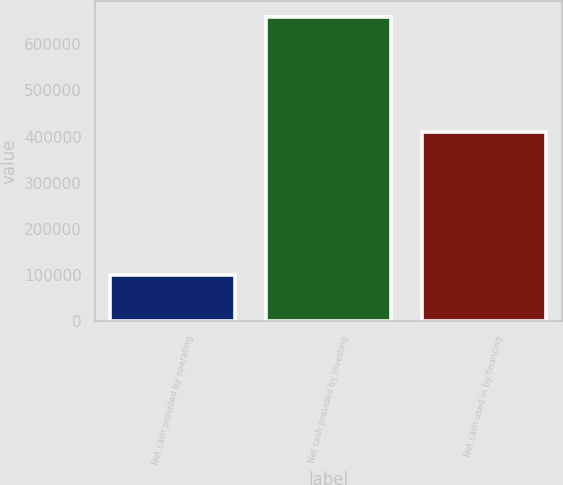Convert chart to OTSL. <chart><loc_0><loc_0><loc_500><loc_500><bar_chart><fcel>Net cash provided by operating<fcel>Net cash provided by investing<fcel>Net cash used in by financing<nl><fcel>101464<fcel>659648<fcel>409156<nl></chart> 